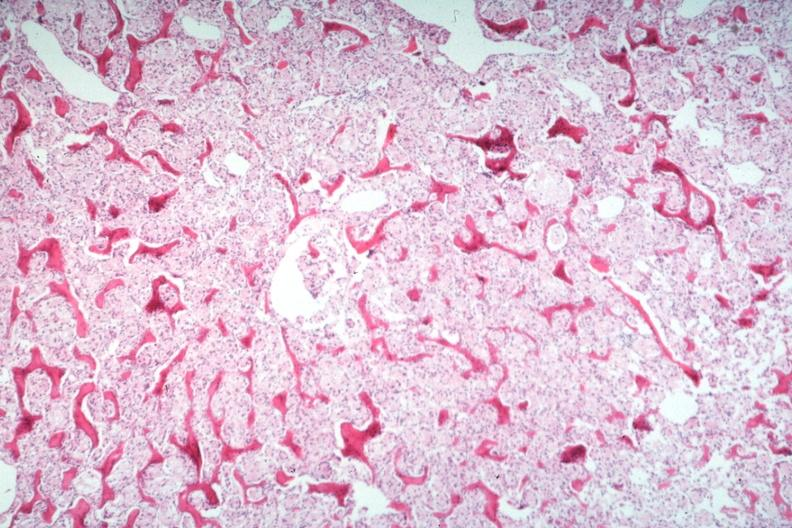s cells present?
Answer the question using a single word or phrase. No 